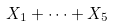<formula> <loc_0><loc_0><loc_500><loc_500>X _ { 1 } + \dots + X _ { 5 }</formula> 